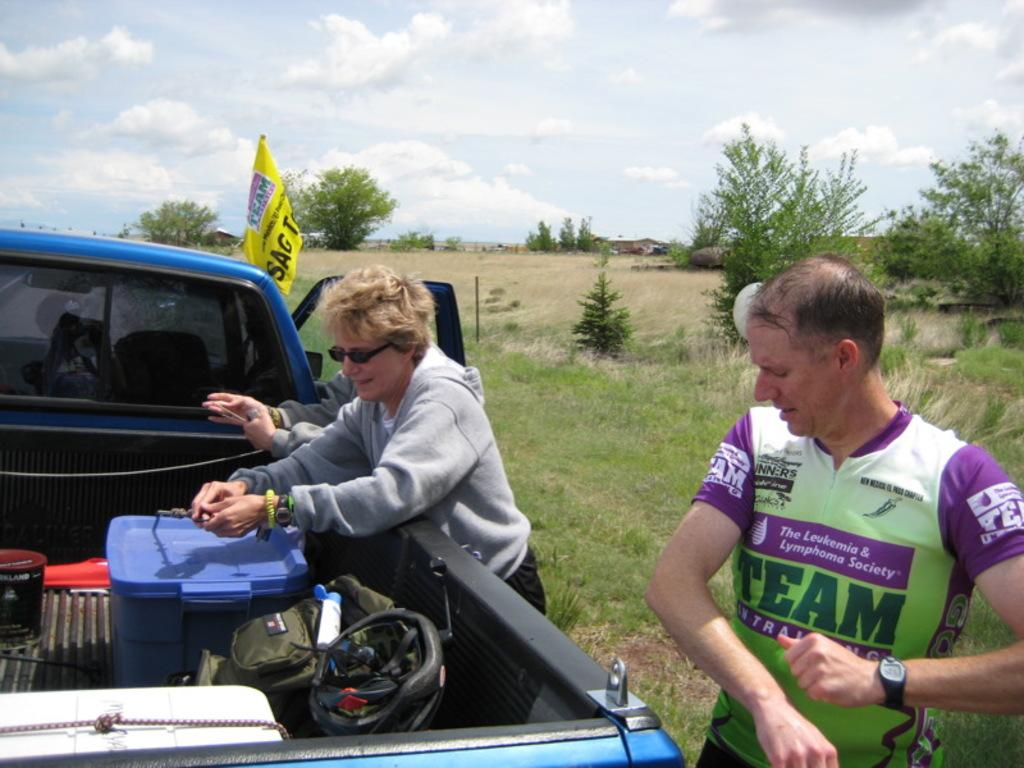How many people are present in the image? There are three persons standing in the image. What can be seen on the truck in the image? There are objects on a truck in the image. What object in the image resembles a flag? There is an object that resembles a flag in the image. What type of natural vegetation is visible in the image? There are trees in the image. What is visible in the background of the image? The sky is visible in the background of the image. What type of line can be seen connecting the trees in the image? There is no line connecting the trees in the image; the trees are separate entities. What type of quartz is visible in the image? There is no quartz present in the image. 